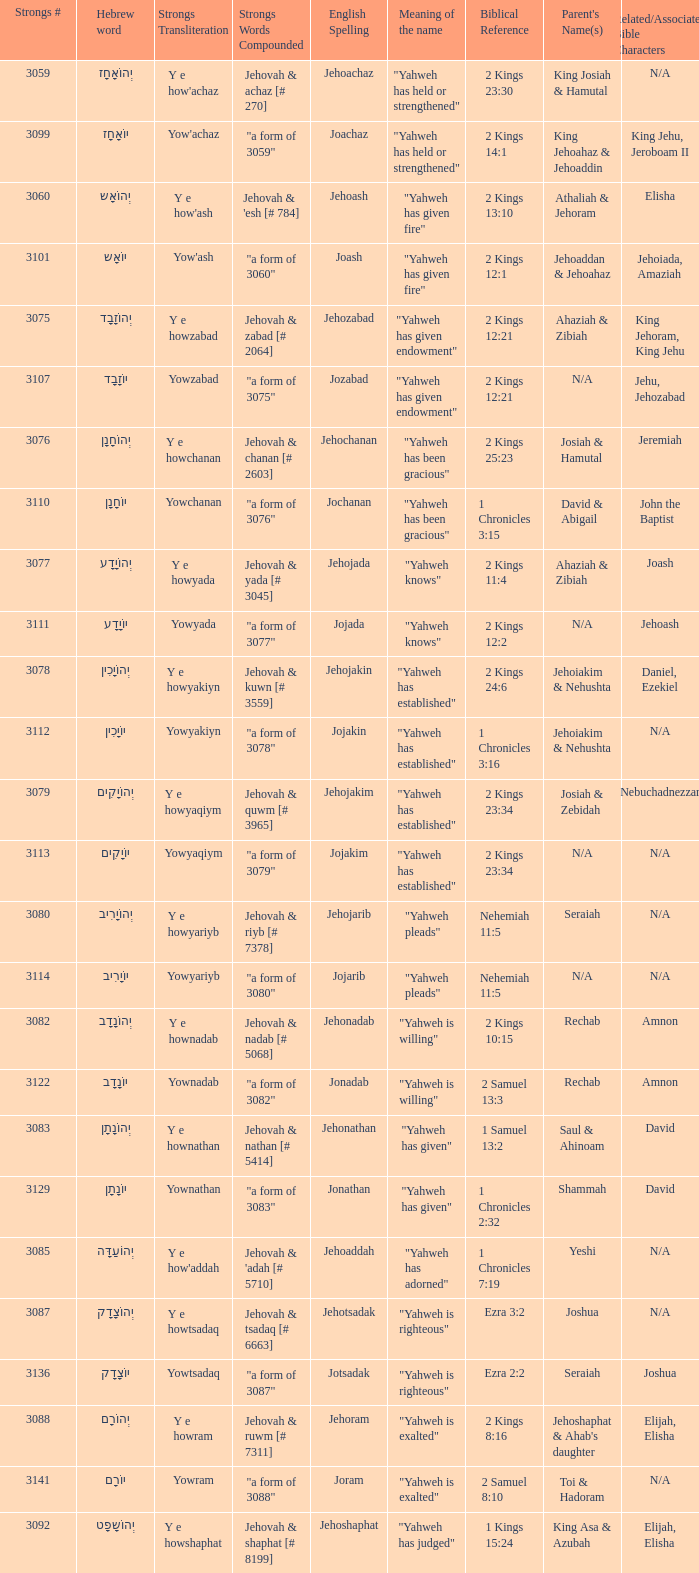What is the strongs # of the english spelling word jehojakin? 3078.0. 